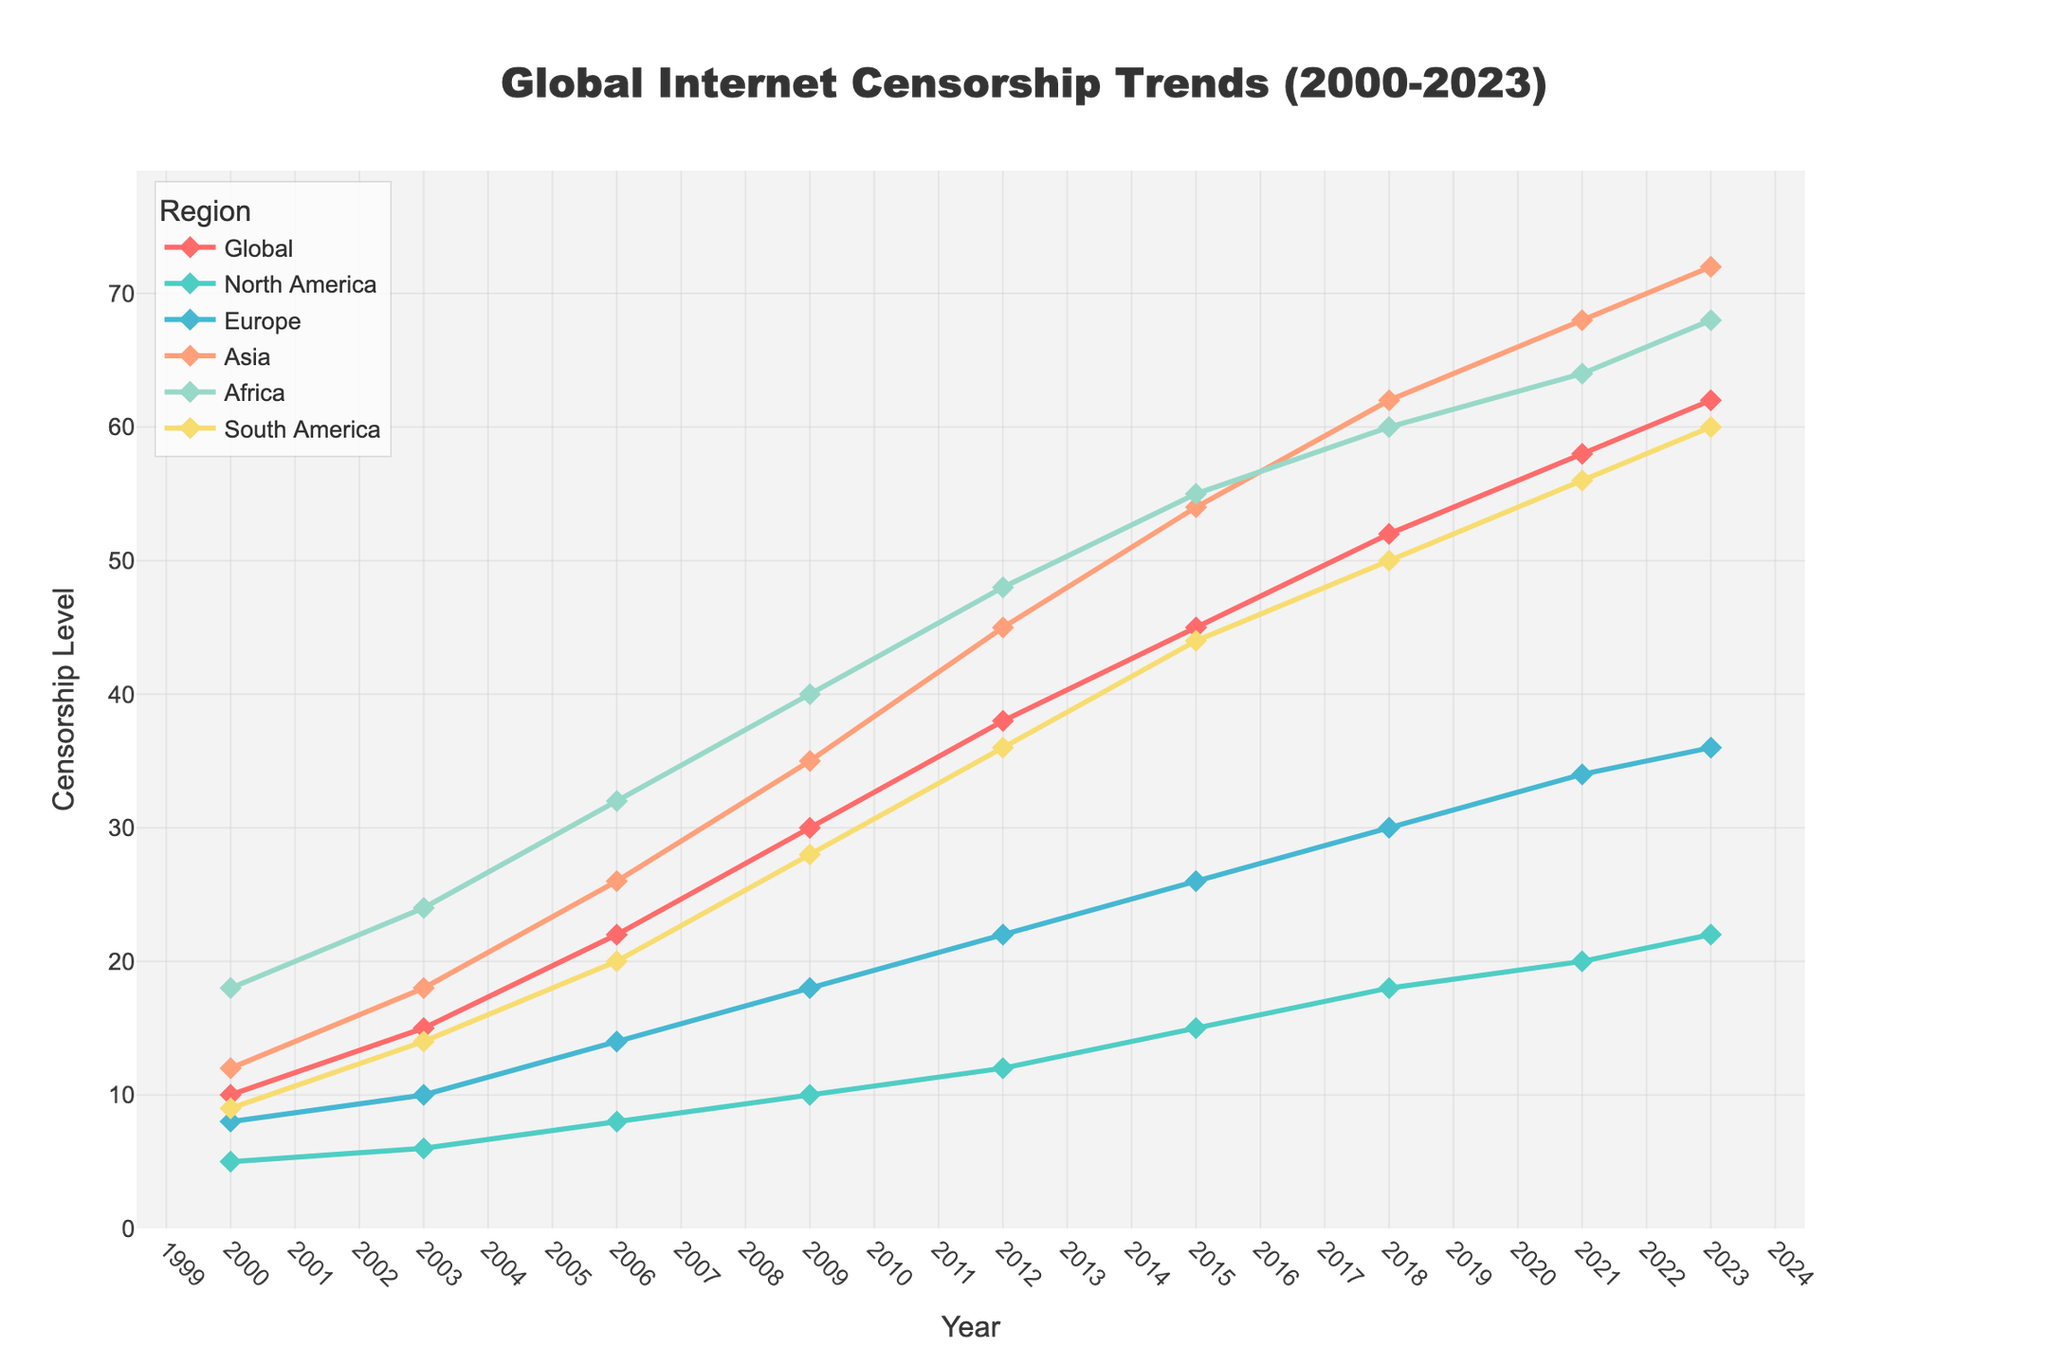Which region had the highest internet censorship level in 2021? To find the highest internet censorship level in 2021, locate the 2021 data point and compare the values for each region. Asia had 68, the highest among all regions.
Answer: Asia What is the overall trend of internet censorship globally from 2000 to 2023? Look at the line representing the global trend from 2000 to 2023. The line consistently increases indicating a steady rise in global internet censorship levels over time.
Answer: Increasing trend By how much did internet censorship in North America increase from 2000 to 2023? Subtract the censorship level in North America in 2000 (5) from the level in 2023 (22). So, 22 - 5 = 17.
Answer: 17 Which region showed the smallest increase in censorship levels from 2000 to 2023? Calculate the increase for each region by subtracting the 2000 value from the 2023 value, then find the smallest increase. North America had the smallest increase, from 5 to 22, which is 17.
Answer: North America In which year did South America surpass North America in censorship levels? Compare the trends for South America and North America year by year till South America’s value exceeds North America’s. This first occurs in 2003, where South America has 14 and North America has 6.
Answer: 2003 What were the global internet censorship levels in 2009 and 2021, and how much did they change? Find the global levels for 2009 (30) and 2021 (58), then calculate the difference by subtracting the former from the latter: 58 - 30 = 28.
Answer: 28 Which region had the steepest increase between 2015 and 2023? Determine the difference in censorship levels for each region between 2015 and 2023, then identify the largest difference. Asia increased from 54 to 72, the highest increase of 18.
Answer: Asia How does Africa's censorship level in 2006 compare to Europe's level in the same year? Locate the 2006 censorship levels for Africa and Europe. Africa had a level of 32, and Europe had a level of 14, so Africa's level is higher.
Answer: Africa is higher By how many points did global internet censorship increase between each year on average? Calculate the total increase from 2000 (10) to 2023 (62), which is 52 points, then divide by the number of periods (2023-2000 = 23 years). The average yearly increase is 52 / 23 ≈ 2.26.
Answer: 2.26 What is the difference in censorship levels between Asia and South America in 2023? Subtract South America's level in 2023 (60) from Asia's level in 2023 (72). So, 72 - 60 = 12.
Answer: 12 